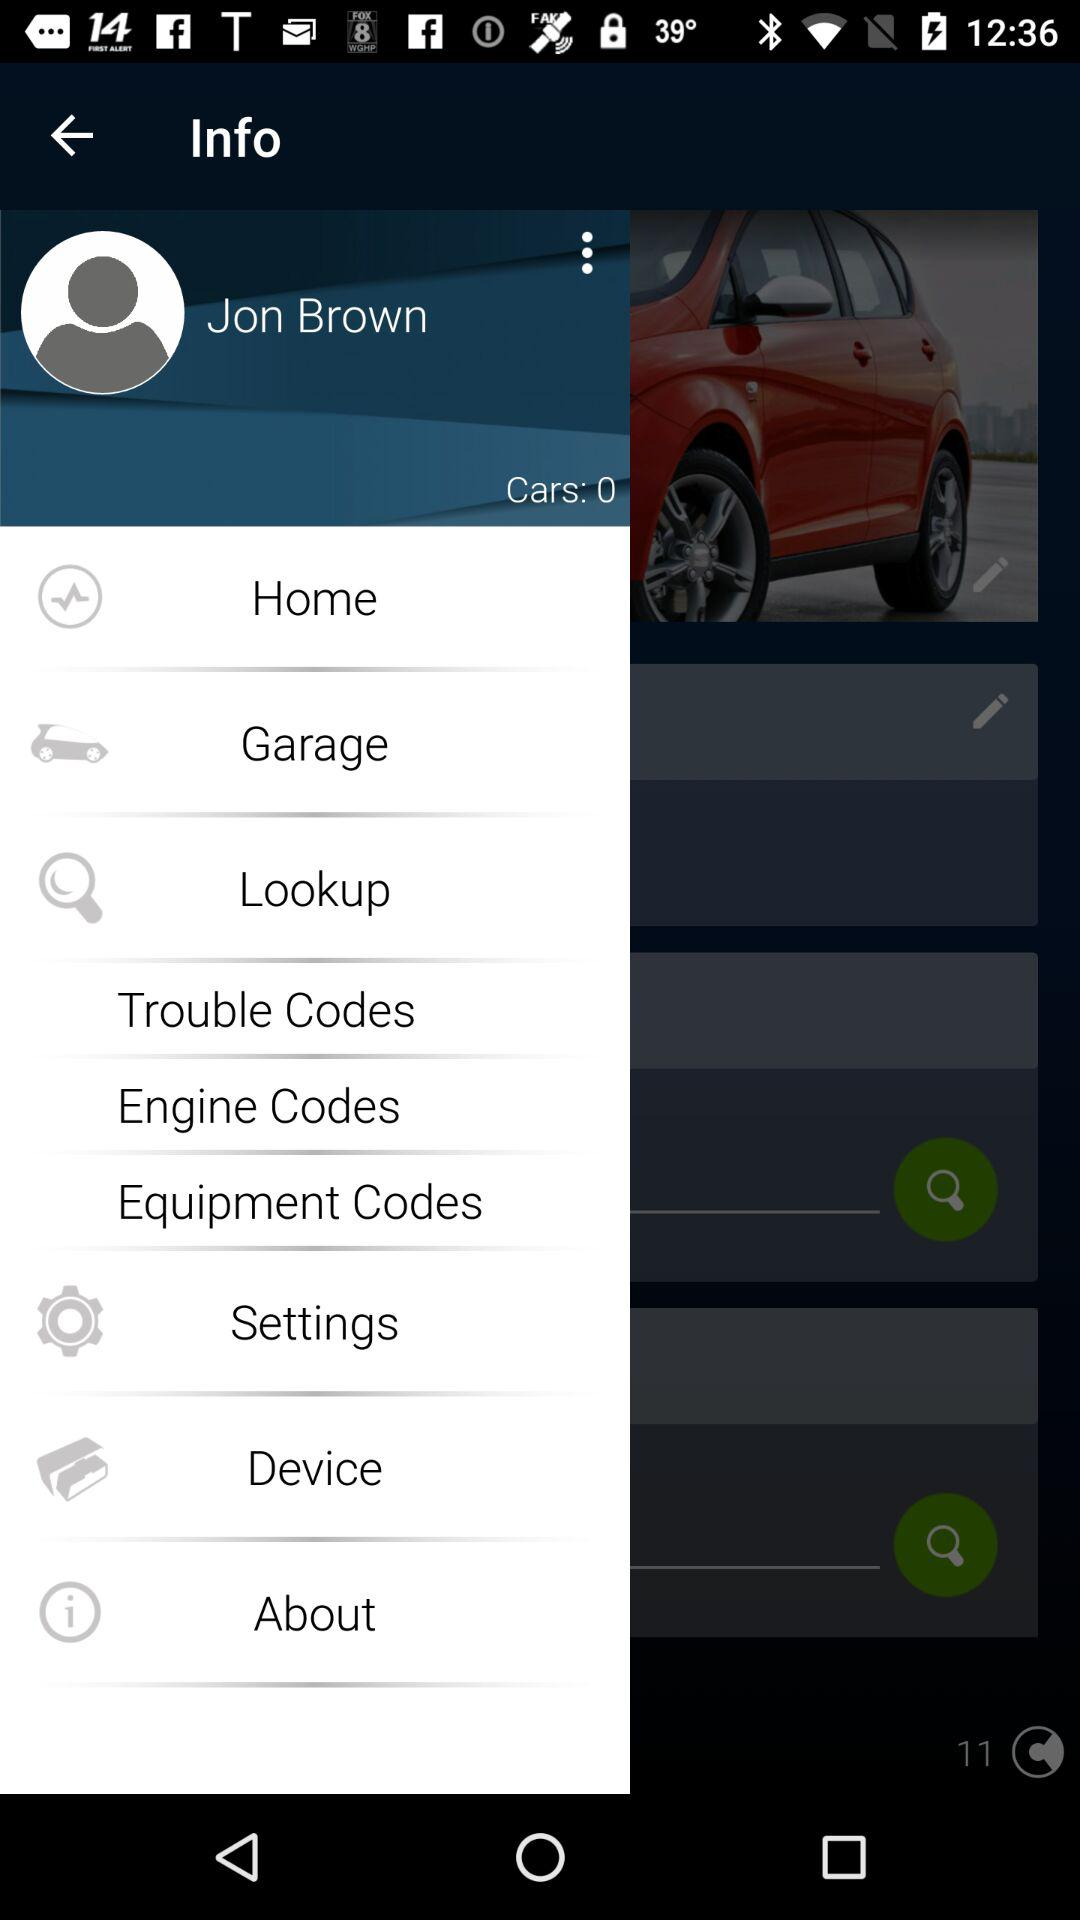How many users are online?
When the provided information is insufficient, respond with <no answer>. <no answer> 